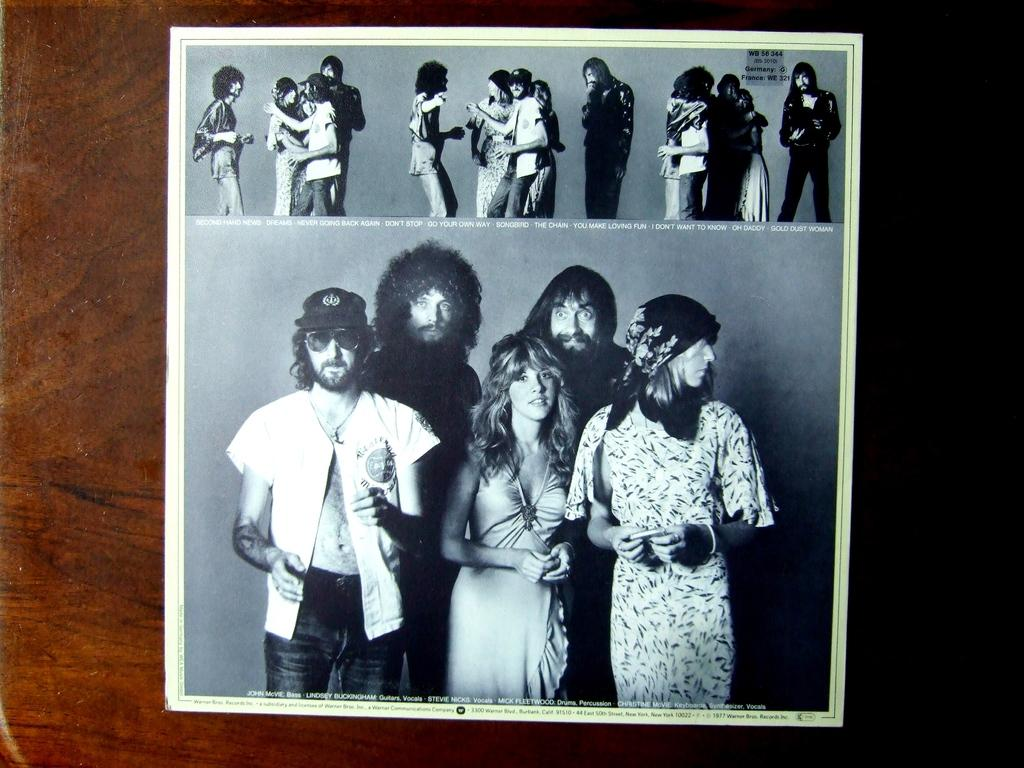What is the main subject of the image? The main subject of the image is a photograph. Where is the photograph located? The photograph is pasted on a wooden wall. What can be seen in the photograph? There are people standing in the photograph, and there is text in the photograph. What time of day is it in the photograph? The time of day cannot be determined from the image, as there is no indication of the time in the photograph or the surrounding context. 